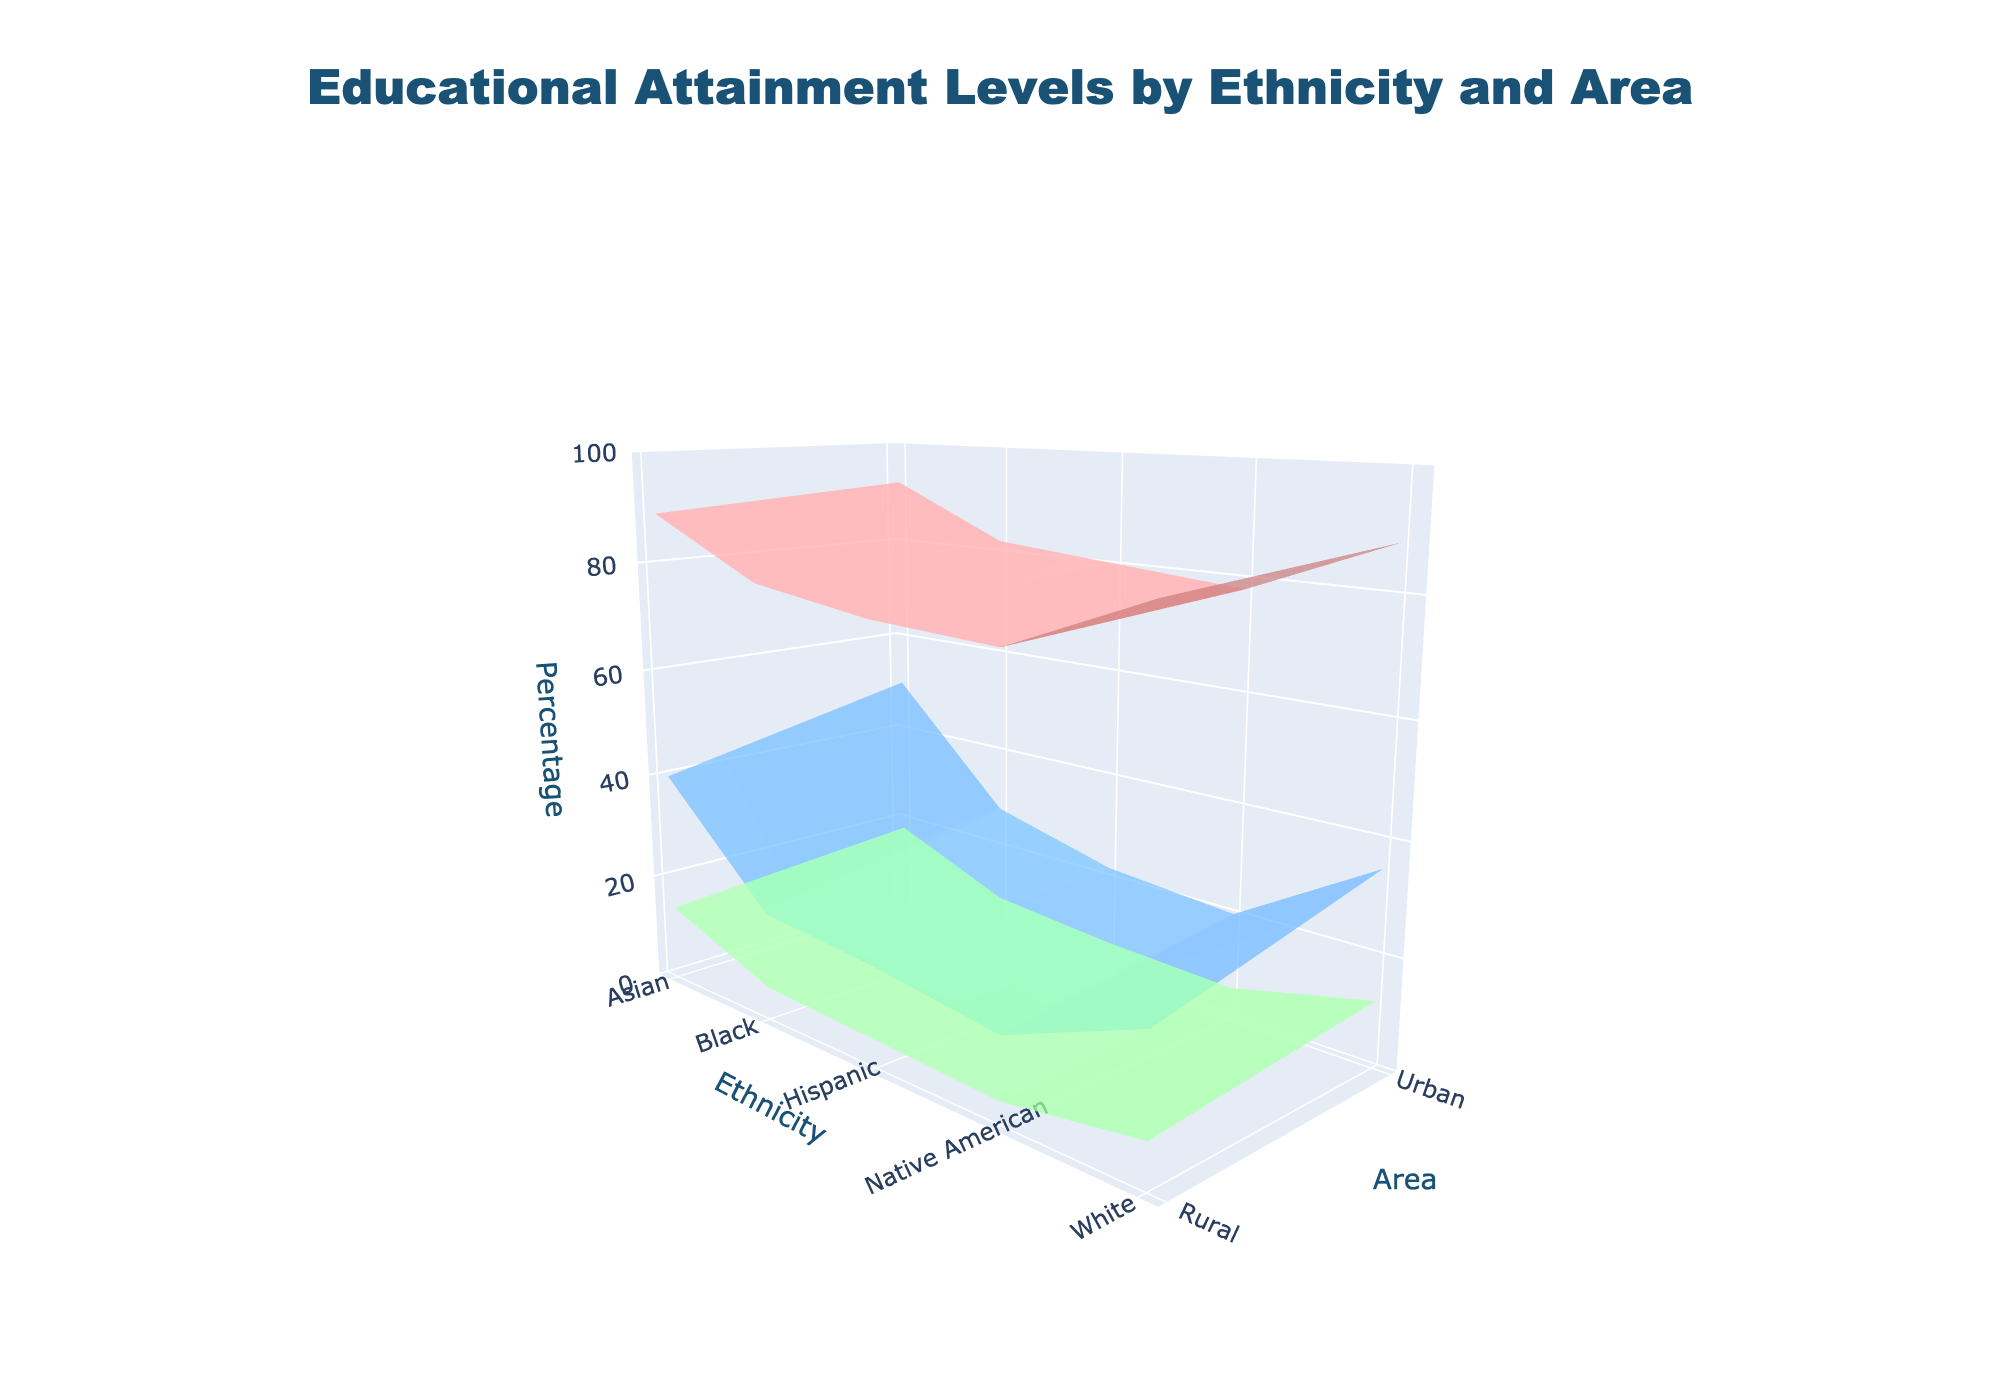What is the title of the figure? The title is located at the very top of the figure. It is clearly indicated and designed to provide context about what the figure represents.
Answer: Educational Attainment Levels by Ethnicity and Area How many ethnicities are shown in the figure? The x-axis represents Ethnicity. By counting the unique categories on the x-axis, we can determine the number of ethnicities displayed.
Answer: 5 Which ethnic group has the highest percentage of Master's degrees in urban areas? Locate the portion of the figure that covers Master's degrees (typically color-coded). Then compare the heights of the surfaces across the ethnic groups in the urban segment.
Answer: Asian What is the difference in Bachelor's degree attainment between urban and rural areas for Hispanic individuals? First, locate the heights corresponding to Bachelor's degrees for Hispanics in both urban and rural segments. Then, subtract the rural percentage from the urban percentage.
Answer: 4% Which area shows a higher percentage of high school graduates among Native Americans? Compare the surfaces corresponding to High School graduates for Native Americans across urban and rural areas, and identify which is higher.
Answer: Urban What is the average percentage of Master's degrees across all ethnic groups in rural areas? Find the heights of the Master's degree surfaces for each ethnic group in rural areas. Sum these percentages and divide by the number of ethnic groups to calculate the average.
Answer: 7.4% Which ethnic group experiences the largest disparity in Bachelor's degrees between urban and rural areas? For each ethnic group, find the difference in Bachelor's degree percentages between urban and rural areas. Identify the group with the largest difference.
Answer: Asian Which educational attainment level shows the least variation between urban and rural areas for all ethnic groups combined? Review the surface plot sections for high school, Bachelor's, and Master's degrees across all ethnic groups. Compare the general variation in heights between urban and rural areas to determine which has the least variation.
Answer: High School What percentage of urban Asian individuals have at least a Bachelor's degree? Find the heights for Bachelor's and Master's degrees for urban Asian individuals. Sum these values to get the total percentage for at least a Bachelor's degree.
Answer: 68% Between White and Black ethnicities, which one has a higher percentage of high school graduates in rural areas? Compare the heights for High School graduates from White and Black ethnicities in rural areas and identify which is higher.
Answer: White 